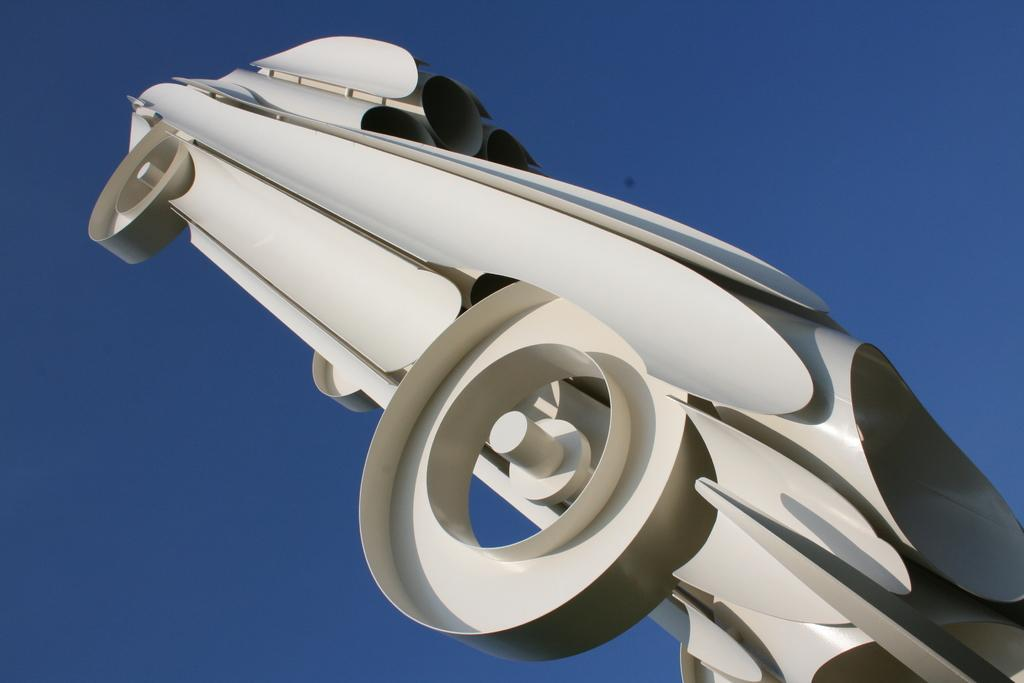What is the main subject of the image? There is an object in the shape of a car in the image. Can you describe the color of the car-shaped object? The car-shaped object is white in color. What can be seen in the background of the image? The background of the image is blue. How many monkeys are sitting on the car-shaped object in the image? There are no monkeys present in the image; it only features a car-shaped object. What type of adjustment can be seen being made to the car-shaped object in the image? There is no adjustment being made to the car-shaped object in the image; it is stationary. 